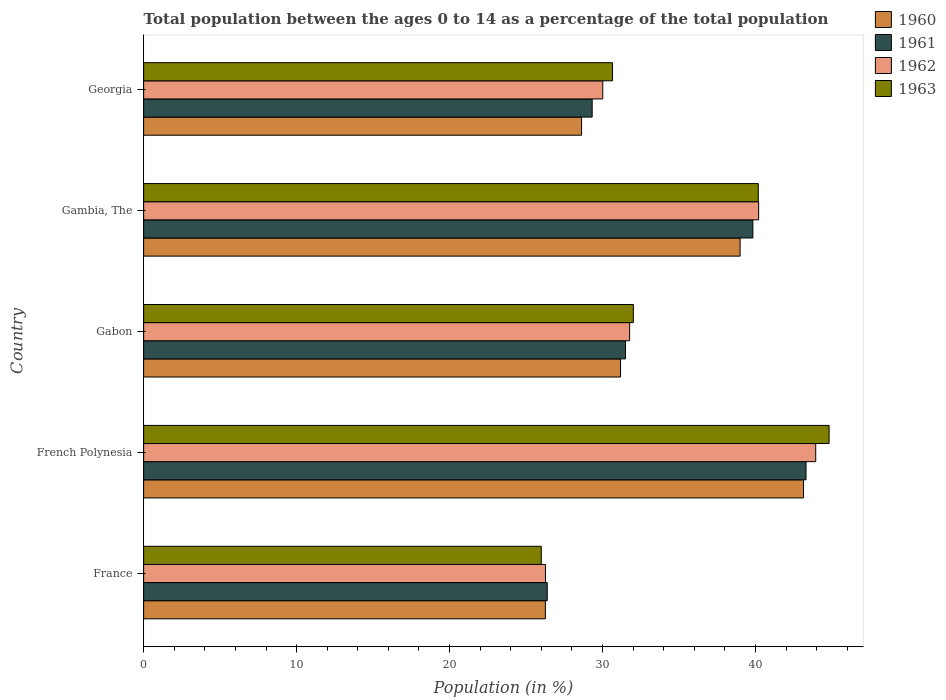How many different coloured bars are there?
Provide a succinct answer. 4. How many groups of bars are there?
Provide a succinct answer. 5. Are the number of bars per tick equal to the number of legend labels?
Offer a terse response. Yes. Are the number of bars on each tick of the Y-axis equal?
Give a very brief answer. Yes. What is the label of the 4th group of bars from the top?
Ensure brevity in your answer.  French Polynesia. In how many cases, is the number of bars for a given country not equal to the number of legend labels?
Keep it short and to the point. 0. What is the percentage of the population ages 0 to 14 in 1960 in Gambia, The?
Offer a terse response. 39. Across all countries, what is the maximum percentage of the population ages 0 to 14 in 1961?
Offer a very short reply. 43.31. Across all countries, what is the minimum percentage of the population ages 0 to 14 in 1960?
Provide a succinct answer. 26.27. In which country was the percentage of the population ages 0 to 14 in 1962 maximum?
Offer a very short reply. French Polynesia. In which country was the percentage of the population ages 0 to 14 in 1963 minimum?
Keep it short and to the point. France. What is the total percentage of the population ages 0 to 14 in 1960 in the graph?
Provide a succinct answer. 168.21. What is the difference between the percentage of the population ages 0 to 14 in 1963 in France and that in Gabon?
Provide a succinct answer. -6.02. What is the difference between the percentage of the population ages 0 to 14 in 1962 in France and the percentage of the population ages 0 to 14 in 1961 in Gabon?
Your answer should be compact. -5.23. What is the average percentage of the population ages 0 to 14 in 1962 per country?
Your response must be concise. 34.44. What is the difference between the percentage of the population ages 0 to 14 in 1963 and percentage of the population ages 0 to 14 in 1961 in Gambia, The?
Give a very brief answer. 0.35. What is the ratio of the percentage of the population ages 0 to 14 in 1962 in France to that in Georgia?
Keep it short and to the point. 0.88. Is the percentage of the population ages 0 to 14 in 1963 in France less than that in French Polynesia?
Offer a terse response. Yes. What is the difference between the highest and the second highest percentage of the population ages 0 to 14 in 1963?
Your response must be concise. 4.63. What is the difference between the highest and the lowest percentage of the population ages 0 to 14 in 1961?
Give a very brief answer. 16.92. Is it the case that in every country, the sum of the percentage of the population ages 0 to 14 in 1960 and percentage of the population ages 0 to 14 in 1963 is greater than the sum of percentage of the population ages 0 to 14 in 1962 and percentage of the population ages 0 to 14 in 1961?
Your response must be concise. No. How many bars are there?
Your answer should be compact. 20. Are all the bars in the graph horizontal?
Your response must be concise. Yes. How many countries are there in the graph?
Your answer should be compact. 5. Does the graph contain any zero values?
Keep it short and to the point. No. Does the graph contain grids?
Offer a very short reply. No. What is the title of the graph?
Your answer should be very brief. Total population between the ages 0 to 14 as a percentage of the total population. What is the label or title of the Y-axis?
Your answer should be compact. Country. What is the Population (in %) of 1960 in France?
Your answer should be very brief. 26.27. What is the Population (in %) of 1961 in France?
Provide a short and direct response. 26.39. What is the Population (in %) of 1962 in France?
Provide a succinct answer. 26.27. What is the Population (in %) in 1963 in France?
Give a very brief answer. 26. What is the Population (in %) of 1960 in French Polynesia?
Offer a terse response. 43.14. What is the Population (in %) in 1961 in French Polynesia?
Your response must be concise. 43.31. What is the Population (in %) in 1962 in French Polynesia?
Keep it short and to the point. 43.94. What is the Population (in %) in 1963 in French Polynesia?
Provide a succinct answer. 44.81. What is the Population (in %) of 1960 in Gabon?
Give a very brief answer. 31.18. What is the Population (in %) in 1961 in Gabon?
Your answer should be very brief. 31.5. What is the Population (in %) in 1962 in Gabon?
Your response must be concise. 31.77. What is the Population (in %) of 1963 in Gabon?
Offer a terse response. 32.02. What is the Population (in %) of 1960 in Gambia, The?
Give a very brief answer. 39. What is the Population (in %) of 1961 in Gambia, The?
Your answer should be very brief. 39.83. What is the Population (in %) in 1962 in Gambia, The?
Make the answer very short. 40.21. What is the Population (in %) of 1963 in Gambia, The?
Give a very brief answer. 40.18. What is the Population (in %) of 1960 in Georgia?
Provide a short and direct response. 28.63. What is the Population (in %) of 1961 in Georgia?
Your answer should be very brief. 29.32. What is the Population (in %) in 1962 in Georgia?
Your answer should be very brief. 30.02. What is the Population (in %) in 1963 in Georgia?
Provide a succinct answer. 30.65. Across all countries, what is the maximum Population (in %) of 1960?
Provide a succinct answer. 43.14. Across all countries, what is the maximum Population (in %) of 1961?
Make the answer very short. 43.31. Across all countries, what is the maximum Population (in %) in 1962?
Offer a terse response. 43.94. Across all countries, what is the maximum Population (in %) in 1963?
Your response must be concise. 44.81. Across all countries, what is the minimum Population (in %) of 1960?
Ensure brevity in your answer.  26.27. Across all countries, what is the minimum Population (in %) of 1961?
Offer a very short reply. 26.39. Across all countries, what is the minimum Population (in %) of 1962?
Ensure brevity in your answer.  26.27. Across all countries, what is the minimum Population (in %) in 1963?
Provide a succinct answer. 26. What is the total Population (in %) in 1960 in the graph?
Make the answer very short. 168.21. What is the total Population (in %) in 1961 in the graph?
Provide a short and direct response. 170.35. What is the total Population (in %) in 1962 in the graph?
Give a very brief answer. 172.21. What is the total Population (in %) of 1963 in the graph?
Keep it short and to the point. 173.66. What is the difference between the Population (in %) in 1960 in France and that in French Polynesia?
Keep it short and to the point. -16.88. What is the difference between the Population (in %) of 1961 in France and that in French Polynesia?
Offer a terse response. -16.92. What is the difference between the Population (in %) in 1962 in France and that in French Polynesia?
Make the answer very short. -17.67. What is the difference between the Population (in %) of 1963 in France and that in French Polynesia?
Your answer should be very brief. -18.82. What is the difference between the Population (in %) of 1960 in France and that in Gabon?
Your answer should be very brief. -4.91. What is the difference between the Population (in %) of 1961 in France and that in Gabon?
Give a very brief answer. -5.11. What is the difference between the Population (in %) in 1962 in France and that in Gabon?
Your answer should be compact. -5.5. What is the difference between the Population (in %) of 1963 in France and that in Gabon?
Your answer should be very brief. -6.02. What is the difference between the Population (in %) in 1960 in France and that in Gambia, The?
Provide a short and direct response. -12.73. What is the difference between the Population (in %) of 1961 in France and that in Gambia, The?
Your response must be concise. -13.44. What is the difference between the Population (in %) of 1962 in France and that in Gambia, The?
Ensure brevity in your answer.  -13.94. What is the difference between the Population (in %) in 1963 in France and that in Gambia, The?
Keep it short and to the point. -14.19. What is the difference between the Population (in %) of 1960 in France and that in Georgia?
Make the answer very short. -2.37. What is the difference between the Population (in %) of 1961 in France and that in Georgia?
Your response must be concise. -2.94. What is the difference between the Population (in %) of 1962 in France and that in Georgia?
Make the answer very short. -3.74. What is the difference between the Population (in %) of 1963 in France and that in Georgia?
Provide a short and direct response. -4.65. What is the difference between the Population (in %) in 1960 in French Polynesia and that in Gabon?
Give a very brief answer. 11.96. What is the difference between the Population (in %) of 1961 in French Polynesia and that in Gabon?
Your response must be concise. 11.8. What is the difference between the Population (in %) in 1962 in French Polynesia and that in Gabon?
Your answer should be very brief. 12.17. What is the difference between the Population (in %) of 1963 in French Polynesia and that in Gabon?
Your response must be concise. 12.8. What is the difference between the Population (in %) in 1960 in French Polynesia and that in Gambia, The?
Keep it short and to the point. 4.15. What is the difference between the Population (in %) in 1961 in French Polynesia and that in Gambia, The?
Offer a very short reply. 3.48. What is the difference between the Population (in %) in 1962 in French Polynesia and that in Gambia, The?
Offer a terse response. 3.73. What is the difference between the Population (in %) in 1963 in French Polynesia and that in Gambia, The?
Ensure brevity in your answer.  4.63. What is the difference between the Population (in %) in 1960 in French Polynesia and that in Georgia?
Ensure brevity in your answer.  14.51. What is the difference between the Population (in %) in 1961 in French Polynesia and that in Georgia?
Provide a short and direct response. 13.98. What is the difference between the Population (in %) in 1962 in French Polynesia and that in Georgia?
Offer a very short reply. 13.92. What is the difference between the Population (in %) in 1963 in French Polynesia and that in Georgia?
Provide a succinct answer. 14.16. What is the difference between the Population (in %) in 1960 in Gabon and that in Gambia, The?
Make the answer very short. -7.82. What is the difference between the Population (in %) of 1961 in Gabon and that in Gambia, The?
Provide a short and direct response. -8.33. What is the difference between the Population (in %) in 1962 in Gabon and that in Gambia, The?
Provide a succinct answer. -8.43. What is the difference between the Population (in %) of 1963 in Gabon and that in Gambia, The?
Offer a terse response. -8.17. What is the difference between the Population (in %) of 1960 in Gabon and that in Georgia?
Keep it short and to the point. 2.55. What is the difference between the Population (in %) of 1961 in Gabon and that in Georgia?
Your response must be concise. 2.18. What is the difference between the Population (in %) of 1962 in Gabon and that in Georgia?
Make the answer very short. 1.76. What is the difference between the Population (in %) in 1963 in Gabon and that in Georgia?
Your answer should be very brief. 1.37. What is the difference between the Population (in %) of 1960 in Gambia, The and that in Georgia?
Keep it short and to the point. 10.37. What is the difference between the Population (in %) in 1961 in Gambia, The and that in Georgia?
Your answer should be compact. 10.51. What is the difference between the Population (in %) in 1962 in Gambia, The and that in Georgia?
Your response must be concise. 10.19. What is the difference between the Population (in %) of 1963 in Gambia, The and that in Georgia?
Make the answer very short. 9.53. What is the difference between the Population (in %) of 1960 in France and the Population (in %) of 1961 in French Polynesia?
Your answer should be very brief. -17.04. What is the difference between the Population (in %) of 1960 in France and the Population (in %) of 1962 in French Polynesia?
Provide a succinct answer. -17.67. What is the difference between the Population (in %) of 1960 in France and the Population (in %) of 1963 in French Polynesia?
Offer a terse response. -18.55. What is the difference between the Population (in %) of 1961 in France and the Population (in %) of 1962 in French Polynesia?
Make the answer very short. -17.55. What is the difference between the Population (in %) of 1961 in France and the Population (in %) of 1963 in French Polynesia?
Your answer should be compact. -18.43. What is the difference between the Population (in %) in 1962 in France and the Population (in %) in 1963 in French Polynesia?
Ensure brevity in your answer.  -18.54. What is the difference between the Population (in %) in 1960 in France and the Population (in %) in 1961 in Gabon?
Make the answer very short. -5.24. What is the difference between the Population (in %) in 1960 in France and the Population (in %) in 1962 in Gabon?
Make the answer very short. -5.51. What is the difference between the Population (in %) of 1960 in France and the Population (in %) of 1963 in Gabon?
Your answer should be very brief. -5.75. What is the difference between the Population (in %) of 1961 in France and the Population (in %) of 1962 in Gabon?
Your response must be concise. -5.39. What is the difference between the Population (in %) of 1961 in France and the Population (in %) of 1963 in Gabon?
Give a very brief answer. -5.63. What is the difference between the Population (in %) in 1962 in France and the Population (in %) in 1963 in Gabon?
Your response must be concise. -5.74. What is the difference between the Population (in %) in 1960 in France and the Population (in %) in 1961 in Gambia, The?
Your response must be concise. -13.56. What is the difference between the Population (in %) in 1960 in France and the Population (in %) in 1962 in Gambia, The?
Your response must be concise. -13.94. What is the difference between the Population (in %) of 1960 in France and the Population (in %) of 1963 in Gambia, The?
Your answer should be very brief. -13.92. What is the difference between the Population (in %) in 1961 in France and the Population (in %) in 1962 in Gambia, The?
Your answer should be very brief. -13.82. What is the difference between the Population (in %) of 1961 in France and the Population (in %) of 1963 in Gambia, The?
Make the answer very short. -13.8. What is the difference between the Population (in %) of 1962 in France and the Population (in %) of 1963 in Gambia, The?
Ensure brevity in your answer.  -13.91. What is the difference between the Population (in %) of 1960 in France and the Population (in %) of 1961 in Georgia?
Offer a terse response. -3.06. What is the difference between the Population (in %) of 1960 in France and the Population (in %) of 1962 in Georgia?
Provide a short and direct response. -3.75. What is the difference between the Population (in %) in 1960 in France and the Population (in %) in 1963 in Georgia?
Your answer should be very brief. -4.39. What is the difference between the Population (in %) of 1961 in France and the Population (in %) of 1962 in Georgia?
Provide a short and direct response. -3.63. What is the difference between the Population (in %) of 1961 in France and the Population (in %) of 1963 in Georgia?
Your answer should be compact. -4.26. What is the difference between the Population (in %) of 1962 in France and the Population (in %) of 1963 in Georgia?
Keep it short and to the point. -4.38. What is the difference between the Population (in %) in 1960 in French Polynesia and the Population (in %) in 1961 in Gabon?
Ensure brevity in your answer.  11.64. What is the difference between the Population (in %) in 1960 in French Polynesia and the Population (in %) in 1962 in Gabon?
Your response must be concise. 11.37. What is the difference between the Population (in %) in 1960 in French Polynesia and the Population (in %) in 1963 in Gabon?
Offer a terse response. 11.13. What is the difference between the Population (in %) of 1961 in French Polynesia and the Population (in %) of 1962 in Gabon?
Provide a succinct answer. 11.53. What is the difference between the Population (in %) in 1961 in French Polynesia and the Population (in %) in 1963 in Gabon?
Provide a short and direct response. 11.29. What is the difference between the Population (in %) in 1962 in French Polynesia and the Population (in %) in 1963 in Gabon?
Provide a succinct answer. 11.92. What is the difference between the Population (in %) in 1960 in French Polynesia and the Population (in %) in 1961 in Gambia, The?
Your answer should be compact. 3.31. What is the difference between the Population (in %) in 1960 in French Polynesia and the Population (in %) in 1962 in Gambia, The?
Your answer should be compact. 2.94. What is the difference between the Population (in %) in 1960 in French Polynesia and the Population (in %) in 1963 in Gambia, The?
Your response must be concise. 2.96. What is the difference between the Population (in %) of 1961 in French Polynesia and the Population (in %) of 1962 in Gambia, The?
Give a very brief answer. 3.1. What is the difference between the Population (in %) of 1961 in French Polynesia and the Population (in %) of 1963 in Gambia, The?
Provide a short and direct response. 3.12. What is the difference between the Population (in %) of 1962 in French Polynesia and the Population (in %) of 1963 in Gambia, The?
Your answer should be very brief. 3.76. What is the difference between the Population (in %) in 1960 in French Polynesia and the Population (in %) in 1961 in Georgia?
Your response must be concise. 13.82. What is the difference between the Population (in %) of 1960 in French Polynesia and the Population (in %) of 1962 in Georgia?
Make the answer very short. 13.13. What is the difference between the Population (in %) of 1960 in French Polynesia and the Population (in %) of 1963 in Georgia?
Keep it short and to the point. 12.49. What is the difference between the Population (in %) of 1961 in French Polynesia and the Population (in %) of 1962 in Georgia?
Keep it short and to the point. 13.29. What is the difference between the Population (in %) of 1961 in French Polynesia and the Population (in %) of 1963 in Georgia?
Make the answer very short. 12.65. What is the difference between the Population (in %) in 1962 in French Polynesia and the Population (in %) in 1963 in Georgia?
Offer a very short reply. 13.29. What is the difference between the Population (in %) of 1960 in Gabon and the Population (in %) of 1961 in Gambia, The?
Offer a very short reply. -8.65. What is the difference between the Population (in %) of 1960 in Gabon and the Population (in %) of 1962 in Gambia, The?
Offer a terse response. -9.03. What is the difference between the Population (in %) of 1960 in Gabon and the Population (in %) of 1963 in Gambia, The?
Ensure brevity in your answer.  -9.01. What is the difference between the Population (in %) in 1961 in Gabon and the Population (in %) in 1962 in Gambia, The?
Your answer should be compact. -8.71. What is the difference between the Population (in %) in 1961 in Gabon and the Population (in %) in 1963 in Gambia, The?
Offer a terse response. -8.68. What is the difference between the Population (in %) in 1962 in Gabon and the Population (in %) in 1963 in Gambia, The?
Provide a short and direct response. -8.41. What is the difference between the Population (in %) in 1960 in Gabon and the Population (in %) in 1961 in Georgia?
Provide a succinct answer. 1.85. What is the difference between the Population (in %) in 1960 in Gabon and the Population (in %) in 1962 in Georgia?
Provide a succinct answer. 1.16. What is the difference between the Population (in %) of 1960 in Gabon and the Population (in %) of 1963 in Georgia?
Your answer should be very brief. 0.53. What is the difference between the Population (in %) in 1961 in Gabon and the Population (in %) in 1962 in Georgia?
Ensure brevity in your answer.  1.49. What is the difference between the Population (in %) in 1961 in Gabon and the Population (in %) in 1963 in Georgia?
Your answer should be compact. 0.85. What is the difference between the Population (in %) of 1962 in Gabon and the Population (in %) of 1963 in Georgia?
Give a very brief answer. 1.12. What is the difference between the Population (in %) of 1960 in Gambia, The and the Population (in %) of 1961 in Georgia?
Provide a short and direct response. 9.67. What is the difference between the Population (in %) in 1960 in Gambia, The and the Population (in %) in 1962 in Georgia?
Offer a very short reply. 8.98. What is the difference between the Population (in %) in 1960 in Gambia, The and the Population (in %) in 1963 in Georgia?
Provide a short and direct response. 8.35. What is the difference between the Population (in %) in 1961 in Gambia, The and the Population (in %) in 1962 in Georgia?
Your answer should be compact. 9.81. What is the difference between the Population (in %) in 1961 in Gambia, The and the Population (in %) in 1963 in Georgia?
Ensure brevity in your answer.  9.18. What is the difference between the Population (in %) in 1962 in Gambia, The and the Population (in %) in 1963 in Georgia?
Your answer should be very brief. 9.56. What is the average Population (in %) of 1960 per country?
Keep it short and to the point. 33.64. What is the average Population (in %) in 1961 per country?
Give a very brief answer. 34.07. What is the average Population (in %) of 1962 per country?
Make the answer very short. 34.44. What is the average Population (in %) of 1963 per country?
Your answer should be compact. 34.73. What is the difference between the Population (in %) of 1960 and Population (in %) of 1961 in France?
Offer a terse response. -0.12. What is the difference between the Population (in %) of 1960 and Population (in %) of 1962 in France?
Your answer should be very brief. -0.01. What is the difference between the Population (in %) in 1960 and Population (in %) in 1963 in France?
Provide a succinct answer. 0.27. What is the difference between the Population (in %) in 1961 and Population (in %) in 1962 in France?
Your response must be concise. 0.12. What is the difference between the Population (in %) in 1961 and Population (in %) in 1963 in France?
Offer a terse response. 0.39. What is the difference between the Population (in %) of 1962 and Population (in %) of 1963 in France?
Offer a very short reply. 0.28. What is the difference between the Population (in %) in 1960 and Population (in %) in 1961 in French Polynesia?
Your answer should be very brief. -0.16. What is the difference between the Population (in %) in 1960 and Population (in %) in 1962 in French Polynesia?
Provide a short and direct response. -0.8. What is the difference between the Population (in %) in 1960 and Population (in %) in 1963 in French Polynesia?
Your response must be concise. -1.67. What is the difference between the Population (in %) of 1961 and Population (in %) of 1962 in French Polynesia?
Keep it short and to the point. -0.63. What is the difference between the Population (in %) of 1961 and Population (in %) of 1963 in French Polynesia?
Give a very brief answer. -1.51. What is the difference between the Population (in %) in 1962 and Population (in %) in 1963 in French Polynesia?
Offer a terse response. -0.87. What is the difference between the Population (in %) of 1960 and Population (in %) of 1961 in Gabon?
Provide a short and direct response. -0.32. What is the difference between the Population (in %) in 1960 and Population (in %) in 1962 in Gabon?
Your response must be concise. -0.59. What is the difference between the Population (in %) of 1960 and Population (in %) of 1963 in Gabon?
Provide a short and direct response. -0.84. What is the difference between the Population (in %) of 1961 and Population (in %) of 1962 in Gabon?
Keep it short and to the point. -0.27. What is the difference between the Population (in %) of 1961 and Population (in %) of 1963 in Gabon?
Provide a succinct answer. -0.51. What is the difference between the Population (in %) in 1962 and Population (in %) in 1963 in Gabon?
Your response must be concise. -0.24. What is the difference between the Population (in %) in 1960 and Population (in %) in 1961 in Gambia, The?
Provide a succinct answer. -0.83. What is the difference between the Population (in %) in 1960 and Population (in %) in 1962 in Gambia, The?
Give a very brief answer. -1.21. What is the difference between the Population (in %) in 1960 and Population (in %) in 1963 in Gambia, The?
Offer a very short reply. -1.19. What is the difference between the Population (in %) of 1961 and Population (in %) of 1962 in Gambia, The?
Ensure brevity in your answer.  -0.38. What is the difference between the Population (in %) of 1961 and Population (in %) of 1963 in Gambia, The?
Your answer should be very brief. -0.35. What is the difference between the Population (in %) in 1962 and Population (in %) in 1963 in Gambia, The?
Make the answer very short. 0.02. What is the difference between the Population (in %) in 1960 and Population (in %) in 1961 in Georgia?
Offer a terse response. -0.69. What is the difference between the Population (in %) of 1960 and Population (in %) of 1962 in Georgia?
Your response must be concise. -1.38. What is the difference between the Population (in %) in 1960 and Population (in %) in 1963 in Georgia?
Your answer should be very brief. -2.02. What is the difference between the Population (in %) in 1961 and Population (in %) in 1962 in Georgia?
Give a very brief answer. -0.69. What is the difference between the Population (in %) in 1961 and Population (in %) in 1963 in Georgia?
Give a very brief answer. -1.33. What is the difference between the Population (in %) in 1962 and Population (in %) in 1963 in Georgia?
Your response must be concise. -0.63. What is the ratio of the Population (in %) in 1960 in France to that in French Polynesia?
Provide a succinct answer. 0.61. What is the ratio of the Population (in %) of 1961 in France to that in French Polynesia?
Provide a succinct answer. 0.61. What is the ratio of the Population (in %) in 1962 in France to that in French Polynesia?
Give a very brief answer. 0.6. What is the ratio of the Population (in %) of 1963 in France to that in French Polynesia?
Give a very brief answer. 0.58. What is the ratio of the Population (in %) in 1960 in France to that in Gabon?
Keep it short and to the point. 0.84. What is the ratio of the Population (in %) in 1961 in France to that in Gabon?
Make the answer very short. 0.84. What is the ratio of the Population (in %) in 1962 in France to that in Gabon?
Keep it short and to the point. 0.83. What is the ratio of the Population (in %) in 1963 in France to that in Gabon?
Offer a very short reply. 0.81. What is the ratio of the Population (in %) of 1960 in France to that in Gambia, The?
Make the answer very short. 0.67. What is the ratio of the Population (in %) in 1961 in France to that in Gambia, The?
Give a very brief answer. 0.66. What is the ratio of the Population (in %) in 1962 in France to that in Gambia, The?
Make the answer very short. 0.65. What is the ratio of the Population (in %) of 1963 in France to that in Gambia, The?
Provide a succinct answer. 0.65. What is the ratio of the Population (in %) in 1960 in France to that in Georgia?
Offer a very short reply. 0.92. What is the ratio of the Population (in %) in 1961 in France to that in Georgia?
Offer a terse response. 0.9. What is the ratio of the Population (in %) in 1962 in France to that in Georgia?
Provide a succinct answer. 0.88. What is the ratio of the Population (in %) of 1963 in France to that in Georgia?
Give a very brief answer. 0.85. What is the ratio of the Population (in %) in 1960 in French Polynesia to that in Gabon?
Offer a very short reply. 1.38. What is the ratio of the Population (in %) of 1961 in French Polynesia to that in Gabon?
Provide a short and direct response. 1.37. What is the ratio of the Population (in %) in 1962 in French Polynesia to that in Gabon?
Your answer should be compact. 1.38. What is the ratio of the Population (in %) in 1963 in French Polynesia to that in Gabon?
Keep it short and to the point. 1.4. What is the ratio of the Population (in %) in 1960 in French Polynesia to that in Gambia, The?
Offer a terse response. 1.11. What is the ratio of the Population (in %) of 1961 in French Polynesia to that in Gambia, The?
Provide a short and direct response. 1.09. What is the ratio of the Population (in %) of 1962 in French Polynesia to that in Gambia, The?
Your response must be concise. 1.09. What is the ratio of the Population (in %) of 1963 in French Polynesia to that in Gambia, The?
Make the answer very short. 1.12. What is the ratio of the Population (in %) of 1960 in French Polynesia to that in Georgia?
Provide a short and direct response. 1.51. What is the ratio of the Population (in %) of 1961 in French Polynesia to that in Georgia?
Provide a short and direct response. 1.48. What is the ratio of the Population (in %) in 1962 in French Polynesia to that in Georgia?
Provide a short and direct response. 1.46. What is the ratio of the Population (in %) of 1963 in French Polynesia to that in Georgia?
Provide a succinct answer. 1.46. What is the ratio of the Population (in %) of 1960 in Gabon to that in Gambia, The?
Provide a succinct answer. 0.8. What is the ratio of the Population (in %) in 1961 in Gabon to that in Gambia, The?
Offer a very short reply. 0.79. What is the ratio of the Population (in %) of 1962 in Gabon to that in Gambia, The?
Give a very brief answer. 0.79. What is the ratio of the Population (in %) in 1963 in Gabon to that in Gambia, The?
Your answer should be compact. 0.8. What is the ratio of the Population (in %) of 1960 in Gabon to that in Georgia?
Ensure brevity in your answer.  1.09. What is the ratio of the Population (in %) in 1961 in Gabon to that in Georgia?
Provide a succinct answer. 1.07. What is the ratio of the Population (in %) of 1962 in Gabon to that in Georgia?
Give a very brief answer. 1.06. What is the ratio of the Population (in %) in 1963 in Gabon to that in Georgia?
Provide a succinct answer. 1.04. What is the ratio of the Population (in %) in 1960 in Gambia, The to that in Georgia?
Your answer should be very brief. 1.36. What is the ratio of the Population (in %) of 1961 in Gambia, The to that in Georgia?
Make the answer very short. 1.36. What is the ratio of the Population (in %) of 1962 in Gambia, The to that in Georgia?
Make the answer very short. 1.34. What is the ratio of the Population (in %) in 1963 in Gambia, The to that in Georgia?
Keep it short and to the point. 1.31. What is the difference between the highest and the second highest Population (in %) of 1960?
Make the answer very short. 4.15. What is the difference between the highest and the second highest Population (in %) of 1961?
Your answer should be compact. 3.48. What is the difference between the highest and the second highest Population (in %) of 1962?
Ensure brevity in your answer.  3.73. What is the difference between the highest and the second highest Population (in %) in 1963?
Offer a very short reply. 4.63. What is the difference between the highest and the lowest Population (in %) in 1960?
Your answer should be compact. 16.88. What is the difference between the highest and the lowest Population (in %) in 1961?
Your answer should be compact. 16.92. What is the difference between the highest and the lowest Population (in %) in 1962?
Your answer should be compact. 17.67. What is the difference between the highest and the lowest Population (in %) in 1963?
Your answer should be very brief. 18.82. 